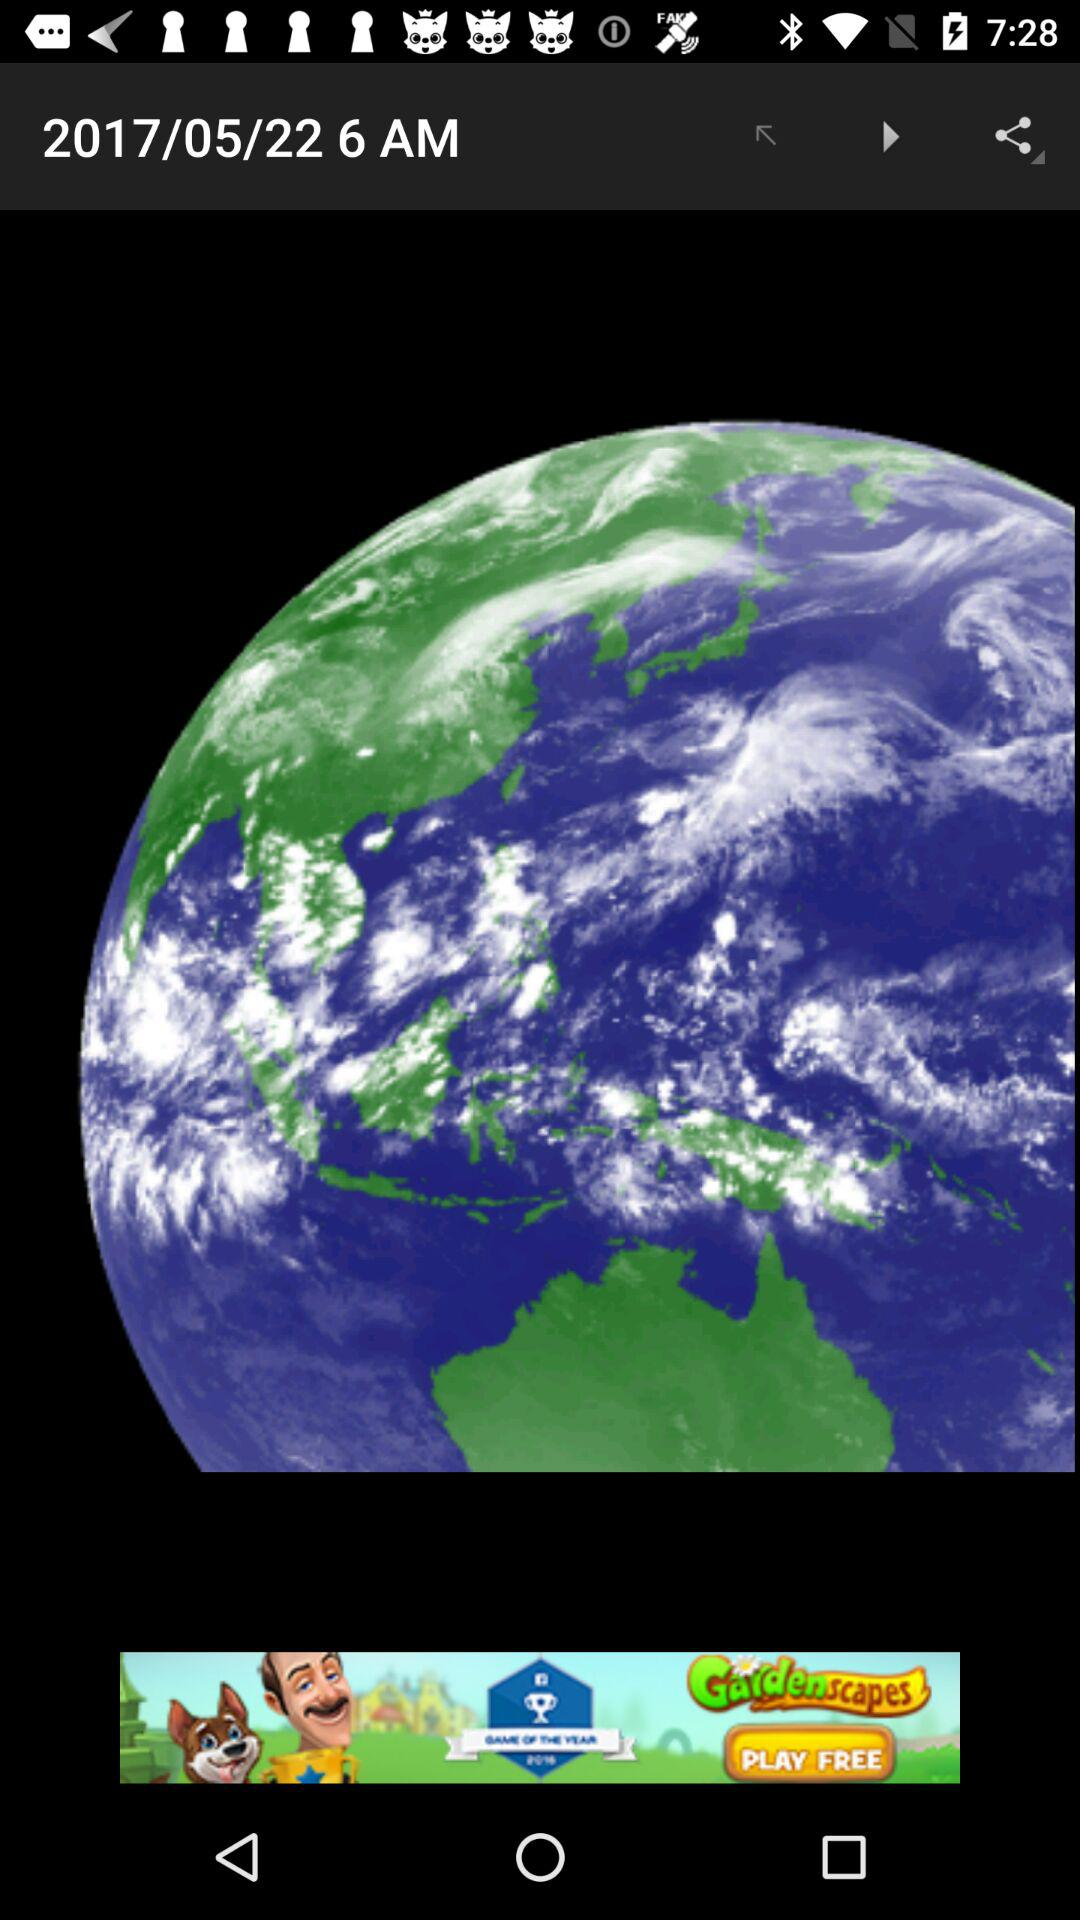What is the date and time? The date is May 22, 2017 and the time is 6 AM. 